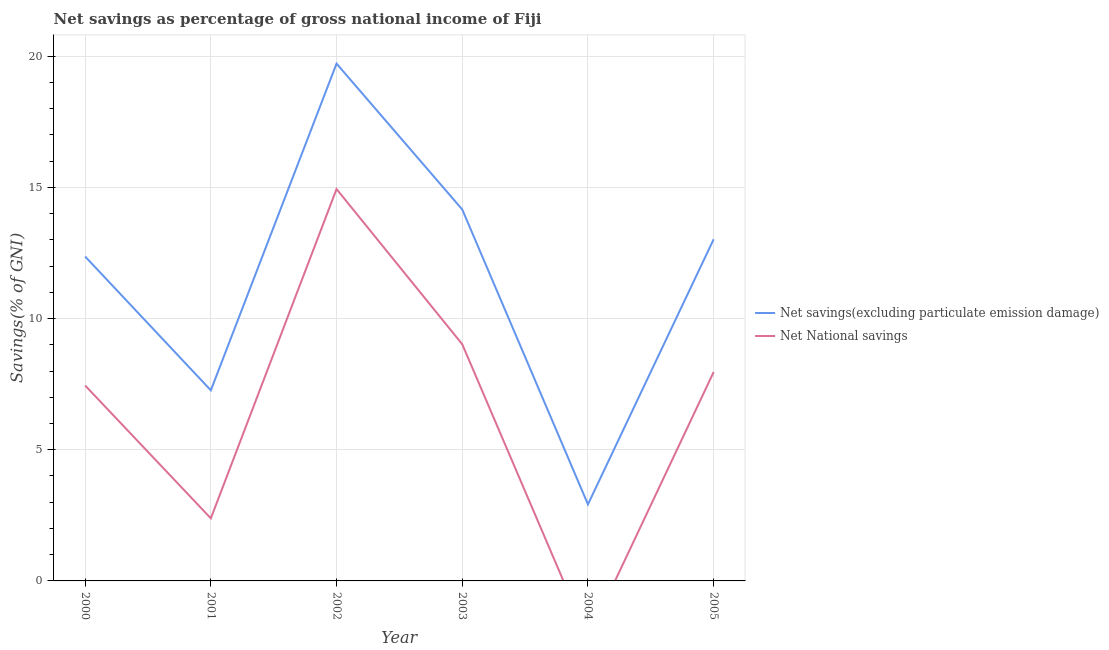How many different coloured lines are there?
Make the answer very short. 2. What is the net savings(excluding particulate emission damage) in 2005?
Offer a terse response. 13.02. Across all years, what is the maximum net savings(excluding particulate emission damage)?
Ensure brevity in your answer.  19.72. Across all years, what is the minimum net national savings?
Provide a succinct answer. 0. What is the total net national savings in the graph?
Keep it short and to the point. 41.75. What is the difference between the net national savings in 2000 and that in 2005?
Ensure brevity in your answer.  -0.51. What is the difference between the net national savings in 2002 and the net savings(excluding particulate emission damage) in 2000?
Provide a short and direct response. 2.57. What is the average net savings(excluding particulate emission damage) per year?
Make the answer very short. 11.57. In the year 2003, what is the difference between the net savings(excluding particulate emission damage) and net national savings?
Your answer should be very brief. 5.14. What is the ratio of the net savings(excluding particulate emission damage) in 2002 to that in 2004?
Provide a succinct answer. 6.76. What is the difference between the highest and the second highest net savings(excluding particulate emission damage)?
Offer a very short reply. 5.56. What is the difference between the highest and the lowest net savings(excluding particulate emission damage)?
Your answer should be very brief. 16.8. In how many years, is the net national savings greater than the average net national savings taken over all years?
Provide a short and direct response. 4. Is the net national savings strictly less than the net savings(excluding particulate emission damage) over the years?
Provide a succinct answer. Yes. How many lines are there?
Your answer should be very brief. 2. Are the values on the major ticks of Y-axis written in scientific E-notation?
Provide a short and direct response. No. Does the graph contain any zero values?
Your answer should be compact. Yes. What is the title of the graph?
Provide a short and direct response. Net savings as percentage of gross national income of Fiji. Does "Age 65(male)" appear as one of the legend labels in the graph?
Offer a very short reply. No. What is the label or title of the X-axis?
Offer a very short reply. Year. What is the label or title of the Y-axis?
Provide a succinct answer. Savings(% of GNI). What is the Savings(% of GNI) in Net savings(excluding particulate emission damage) in 2000?
Make the answer very short. 12.36. What is the Savings(% of GNI) of Net National savings in 2000?
Offer a terse response. 7.45. What is the Savings(% of GNI) in Net savings(excluding particulate emission damage) in 2001?
Your answer should be very brief. 7.26. What is the Savings(% of GNI) in Net National savings in 2001?
Make the answer very short. 2.39. What is the Savings(% of GNI) of Net savings(excluding particulate emission damage) in 2002?
Your answer should be compact. 19.72. What is the Savings(% of GNI) in Net National savings in 2002?
Provide a short and direct response. 14.94. What is the Savings(% of GNI) in Net savings(excluding particulate emission damage) in 2003?
Ensure brevity in your answer.  14.16. What is the Savings(% of GNI) of Net National savings in 2003?
Give a very brief answer. 9.02. What is the Savings(% of GNI) in Net savings(excluding particulate emission damage) in 2004?
Your answer should be very brief. 2.92. What is the Savings(% of GNI) in Net National savings in 2004?
Ensure brevity in your answer.  0. What is the Savings(% of GNI) in Net savings(excluding particulate emission damage) in 2005?
Your answer should be compact. 13.02. What is the Savings(% of GNI) of Net National savings in 2005?
Offer a very short reply. 7.96. Across all years, what is the maximum Savings(% of GNI) in Net savings(excluding particulate emission damage)?
Provide a succinct answer. 19.72. Across all years, what is the maximum Savings(% of GNI) of Net National savings?
Keep it short and to the point. 14.94. Across all years, what is the minimum Savings(% of GNI) in Net savings(excluding particulate emission damage)?
Offer a terse response. 2.92. Across all years, what is the minimum Savings(% of GNI) of Net National savings?
Your response must be concise. 0. What is the total Savings(% of GNI) of Net savings(excluding particulate emission damage) in the graph?
Provide a succinct answer. 69.44. What is the total Savings(% of GNI) of Net National savings in the graph?
Offer a very short reply. 41.75. What is the difference between the Savings(% of GNI) in Net savings(excluding particulate emission damage) in 2000 and that in 2001?
Your response must be concise. 5.1. What is the difference between the Savings(% of GNI) of Net National savings in 2000 and that in 2001?
Provide a succinct answer. 5.06. What is the difference between the Savings(% of GNI) of Net savings(excluding particulate emission damage) in 2000 and that in 2002?
Provide a succinct answer. -7.35. What is the difference between the Savings(% of GNI) in Net National savings in 2000 and that in 2002?
Offer a very short reply. -7.49. What is the difference between the Savings(% of GNI) of Net savings(excluding particulate emission damage) in 2000 and that in 2003?
Ensure brevity in your answer.  -1.79. What is the difference between the Savings(% of GNI) in Net National savings in 2000 and that in 2003?
Make the answer very short. -1.57. What is the difference between the Savings(% of GNI) of Net savings(excluding particulate emission damage) in 2000 and that in 2004?
Keep it short and to the point. 9.45. What is the difference between the Savings(% of GNI) in Net savings(excluding particulate emission damage) in 2000 and that in 2005?
Your response must be concise. -0.66. What is the difference between the Savings(% of GNI) of Net National savings in 2000 and that in 2005?
Your answer should be compact. -0.51. What is the difference between the Savings(% of GNI) of Net savings(excluding particulate emission damage) in 2001 and that in 2002?
Give a very brief answer. -12.45. What is the difference between the Savings(% of GNI) in Net National savings in 2001 and that in 2002?
Provide a succinct answer. -12.55. What is the difference between the Savings(% of GNI) of Net savings(excluding particulate emission damage) in 2001 and that in 2003?
Provide a succinct answer. -6.89. What is the difference between the Savings(% of GNI) in Net National savings in 2001 and that in 2003?
Keep it short and to the point. -6.63. What is the difference between the Savings(% of GNI) in Net savings(excluding particulate emission damage) in 2001 and that in 2004?
Offer a terse response. 4.35. What is the difference between the Savings(% of GNI) in Net savings(excluding particulate emission damage) in 2001 and that in 2005?
Your answer should be compact. -5.76. What is the difference between the Savings(% of GNI) in Net National savings in 2001 and that in 2005?
Keep it short and to the point. -5.58. What is the difference between the Savings(% of GNI) of Net savings(excluding particulate emission damage) in 2002 and that in 2003?
Provide a short and direct response. 5.56. What is the difference between the Savings(% of GNI) in Net National savings in 2002 and that in 2003?
Offer a very short reply. 5.92. What is the difference between the Savings(% of GNI) in Net savings(excluding particulate emission damage) in 2002 and that in 2004?
Offer a very short reply. 16.8. What is the difference between the Savings(% of GNI) in Net savings(excluding particulate emission damage) in 2002 and that in 2005?
Provide a succinct answer. 6.7. What is the difference between the Savings(% of GNI) in Net National savings in 2002 and that in 2005?
Make the answer very short. 6.97. What is the difference between the Savings(% of GNI) of Net savings(excluding particulate emission damage) in 2003 and that in 2004?
Provide a succinct answer. 11.24. What is the difference between the Savings(% of GNI) in Net savings(excluding particulate emission damage) in 2003 and that in 2005?
Your response must be concise. 1.14. What is the difference between the Savings(% of GNI) of Net National savings in 2003 and that in 2005?
Offer a very short reply. 1.06. What is the difference between the Savings(% of GNI) of Net savings(excluding particulate emission damage) in 2004 and that in 2005?
Give a very brief answer. -10.1. What is the difference between the Savings(% of GNI) in Net savings(excluding particulate emission damage) in 2000 and the Savings(% of GNI) in Net National savings in 2001?
Your answer should be compact. 9.98. What is the difference between the Savings(% of GNI) of Net savings(excluding particulate emission damage) in 2000 and the Savings(% of GNI) of Net National savings in 2002?
Provide a succinct answer. -2.57. What is the difference between the Savings(% of GNI) in Net savings(excluding particulate emission damage) in 2000 and the Savings(% of GNI) in Net National savings in 2003?
Give a very brief answer. 3.34. What is the difference between the Savings(% of GNI) in Net savings(excluding particulate emission damage) in 2000 and the Savings(% of GNI) in Net National savings in 2005?
Ensure brevity in your answer.  4.4. What is the difference between the Savings(% of GNI) in Net savings(excluding particulate emission damage) in 2001 and the Savings(% of GNI) in Net National savings in 2002?
Make the answer very short. -7.67. What is the difference between the Savings(% of GNI) in Net savings(excluding particulate emission damage) in 2001 and the Savings(% of GNI) in Net National savings in 2003?
Give a very brief answer. -1.76. What is the difference between the Savings(% of GNI) of Net savings(excluding particulate emission damage) in 2001 and the Savings(% of GNI) of Net National savings in 2005?
Ensure brevity in your answer.  -0.7. What is the difference between the Savings(% of GNI) in Net savings(excluding particulate emission damage) in 2002 and the Savings(% of GNI) in Net National savings in 2003?
Provide a succinct answer. 10.7. What is the difference between the Savings(% of GNI) of Net savings(excluding particulate emission damage) in 2002 and the Savings(% of GNI) of Net National savings in 2005?
Your answer should be compact. 11.75. What is the difference between the Savings(% of GNI) in Net savings(excluding particulate emission damage) in 2003 and the Savings(% of GNI) in Net National savings in 2005?
Give a very brief answer. 6.19. What is the difference between the Savings(% of GNI) in Net savings(excluding particulate emission damage) in 2004 and the Savings(% of GNI) in Net National savings in 2005?
Offer a very short reply. -5.04. What is the average Savings(% of GNI) of Net savings(excluding particulate emission damage) per year?
Your response must be concise. 11.57. What is the average Savings(% of GNI) of Net National savings per year?
Provide a short and direct response. 6.96. In the year 2000, what is the difference between the Savings(% of GNI) of Net savings(excluding particulate emission damage) and Savings(% of GNI) of Net National savings?
Ensure brevity in your answer.  4.92. In the year 2001, what is the difference between the Savings(% of GNI) of Net savings(excluding particulate emission damage) and Savings(% of GNI) of Net National savings?
Provide a succinct answer. 4.88. In the year 2002, what is the difference between the Savings(% of GNI) in Net savings(excluding particulate emission damage) and Savings(% of GNI) in Net National savings?
Your answer should be compact. 4.78. In the year 2003, what is the difference between the Savings(% of GNI) in Net savings(excluding particulate emission damage) and Savings(% of GNI) in Net National savings?
Provide a succinct answer. 5.14. In the year 2005, what is the difference between the Savings(% of GNI) in Net savings(excluding particulate emission damage) and Savings(% of GNI) in Net National savings?
Keep it short and to the point. 5.06. What is the ratio of the Savings(% of GNI) in Net savings(excluding particulate emission damage) in 2000 to that in 2001?
Provide a succinct answer. 1.7. What is the ratio of the Savings(% of GNI) in Net National savings in 2000 to that in 2001?
Your answer should be compact. 3.12. What is the ratio of the Savings(% of GNI) of Net savings(excluding particulate emission damage) in 2000 to that in 2002?
Your answer should be compact. 0.63. What is the ratio of the Savings(% of GNI) of Net National savings in 2000 to that in 2002?
Your answer should be very brief. 0.5. What is the ratio of the Savings(% of GNI) of Net savings(excluding particulate emission damage) in 2000 to that in 2003?
Your answer should be very brief. 0.87. What is the ratio of the Savings(% of GNI) in Net National savings in 2000 to that in 2003?
Provide a succinct answer. 0.83. What is the ratio of the Savings(% of GNI) in Net savings(excluding particulate emission damage) in 2000 to that in 2004?
Make the answer very short. 4.24. What is the ratio of the Savings(% of GNI) in Net savings(excluding particulate emission damage) in 2000 to that in 2005?
Offer a very short reply. 0.95. What is the ratio of the Savings(% of GNI) in Net National savings in 2000 to that in 2005?
Give a very brief answer. 0.94. What is the ratio of the Savings(% of GNI) of Net savings(excluding particulate emission damage) in 2001 to that in 2002?
Ensure brevity in your answer.  0.37. What is the ratio of the Savings(% of GNI) of Net National savings in 2001 to that in 2002?
Keep it short and to the point. 0.16. What is the ratio of the Savings(% of GNI) in Net savings(excluding particulate emission damage) in 2001 to that in 2003?
Offer a very short reply. 0.51. What is the ratio of the Savings(% of GNI) in Net National savings in 2001 to that in 2003?
Your answer should be compact. 0.26. What is the ratio of the Savings(% of GNI) in Net savings(excluding particulate emission damage) in 2001 to that in 2004?
Your answer should be compact. 2.49. What is the ratio of the Savings(% of GNI) of Net savings(excluding particulate emission damage) in 2001 to that in 2005?
Provide a short and direct response. 0.56. What is the ratio of the Savings(% of GNI) of Net National savings in 2001 to that in 2005?
Offer a very short reply. 0.3. What is the ratio of the Savings(% of GNI) in Net savings(excluding particulate emission damage) in 2002 to that in 2003?
Keep it short and to the point. 1.39. What is the ratio of the Savings(% of GNI) in Net National savings in 2002 to that in 2003?
Provide a succinct answer. 1.66. What is the ratio of the Savings(% of GNI) in Net savings(excluding particulate emission damage) in 2002 to that in 2004?
Offer a terse response. 6.76. What is the ratio of the Savings(% of GNI) of Net savings(excluding particulate emission damage) in 2002 to that in 2005?
Make the answer very short. 1.51. What is the ratio of the Savings(% of GNI) of Net National savings in 2002 to that in 2005?
Make the answer very short. 1.88. What is the ratio of the Savings(% of GNI) in Net savings(excluding particulate emission damage) in 2003 to that in 2004?
Your answer should be very brief. 4.85. What is the ratio of the Savings(% of GNI) of Net savings(excluding particulate emission damage) in 2003 to that in 2005?
Provide a succinct answer. 1.09. What is the ratio of the Savings(% of GNI) of Net National savings in 2003 to that in 2005?
Give a very brief answer. 1.13. What is the ratio of the Savings(% of GNI) in Net savings(excluding particulate emission damage) in 2004 to that in 2005?
Offer a terse response. 0.22. What is the difference between the highest and the second highest Savings(% of GNI) in Net savings(excluding particulate emission damage)?
Give a very brief answer. 5.56. What is the difference between the highest and the second highest Savings(% of GNI) of Net National savings?
Provide a succinct answer. 5.92. What is the difference between the highest and the lowest Savings(% of GNI) of Net savings(excluding particulate emission damage)?
Your answer should be compact. 16.8. What is the difference between the highest and the lowest Savings(% of GNI) of Net National savings?
Your response must be concise. 14.94. 